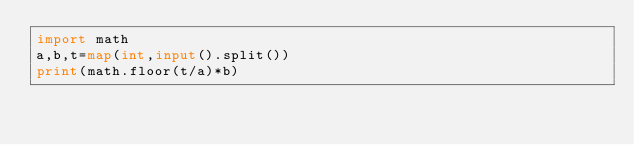Convert code to text. <code><loc_0><loc_0><loc_500><loc_500><_Python_>import math
a,b,t=map(int,input().split())
print(math.floor(t/a)*b)</code> 